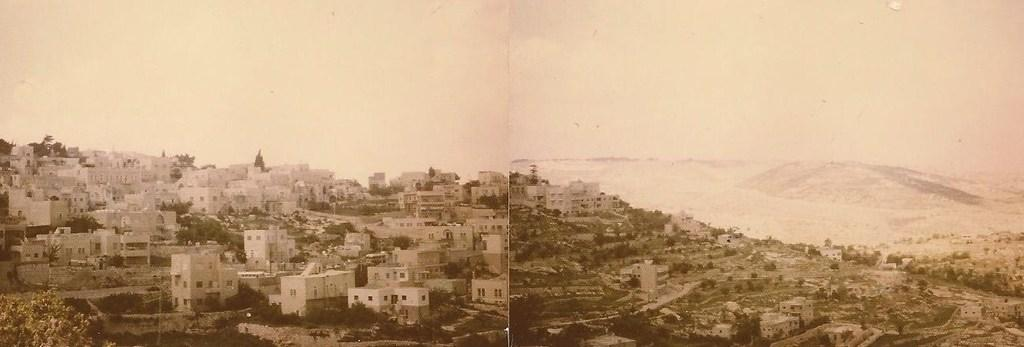How many images are combined to create the collage? The image is a collage of two images. What types of structures can be seen in the images? There are buildings in the images. What type of vegetation is present in the images? There are trees in the images. What is visible in the background of the images? The sky is visible in the background of the images. What type of gold system is depicted in the image? There is no gold system present in the image; it features a collage of two images with buildings, trees, and the sky. Can you see any wounds on the trees in the image? There are no wounds visible on the trees in the image; they appear to be healthy and intact. 